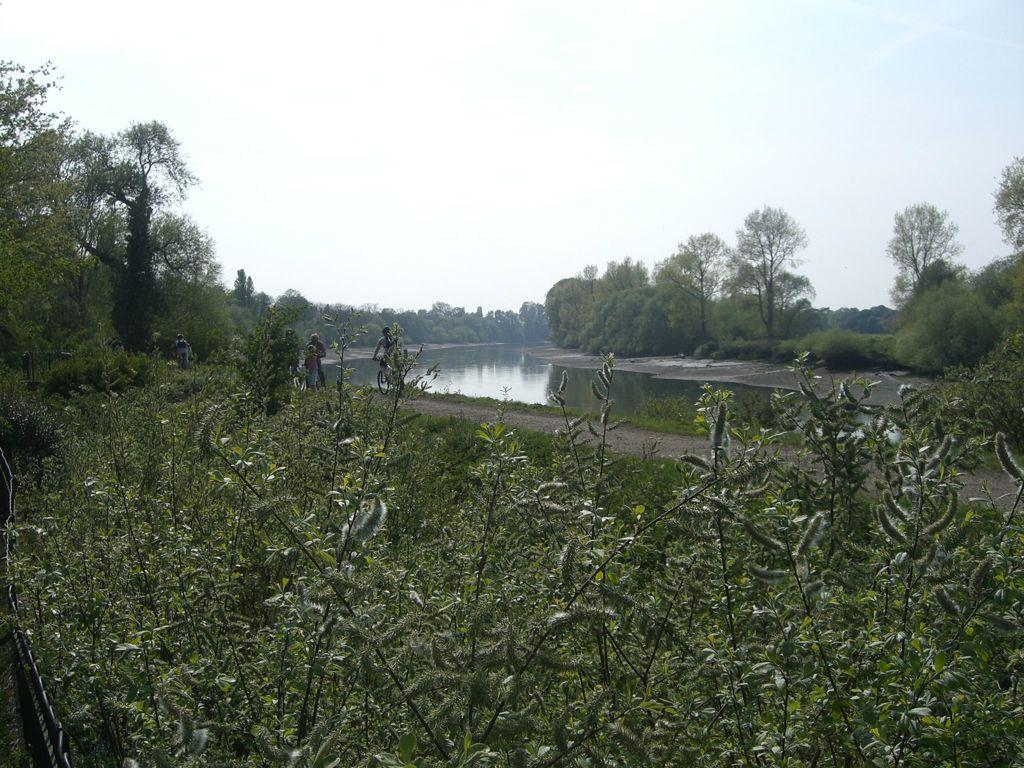What type of vegetation is present in the image? There are many trees and plants in the image. What can be seen in the middle of the image? There is water in the middle of the image. What is visible at the top of the image? The sky is visible at the top of the image. What type of mint can be seen growing in the alley in the image? There is no mint or alley present in the image; it features trees, plants, water, and the sky. What scale is used to measure the size of the trees in the image? There is no scale present in the image to measure the size of the trees. 